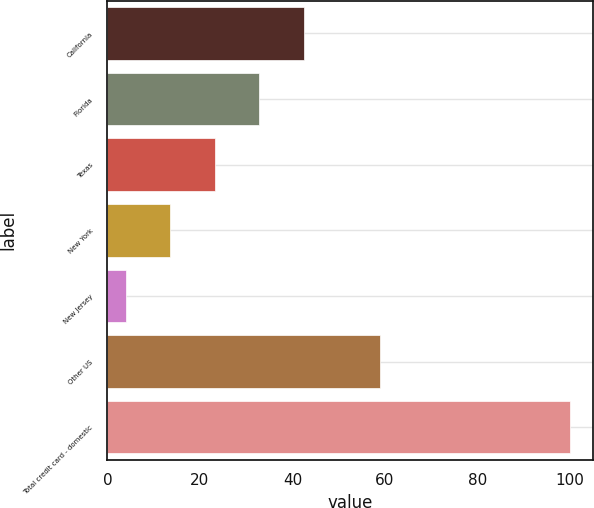Convert chart to OTSL. <chart><loc_0><loc_0><loc_500><loc_500><bar_chart><fcel>California<fcel>Florida<fcel>Texas<fcel>New York<fcel>New Jersey<fcel>Other US<fcel>Total credit card - domestic<nl><fcel>42.4<fcel>32.8<fcel>23.2<fcel>13.6<fcel>4<fcel>58.9<fcel>100<nl></chart> 